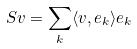Convert formula to latex. <formula><loc_0><loc_0><loc_500><loc_500>S v = \sum _ { k } \langle v , e _ { k } \rangle e _ { k }</formula> 